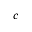<formula> <loc_0><loc_0><loc_500><loc_500>c</formula> 